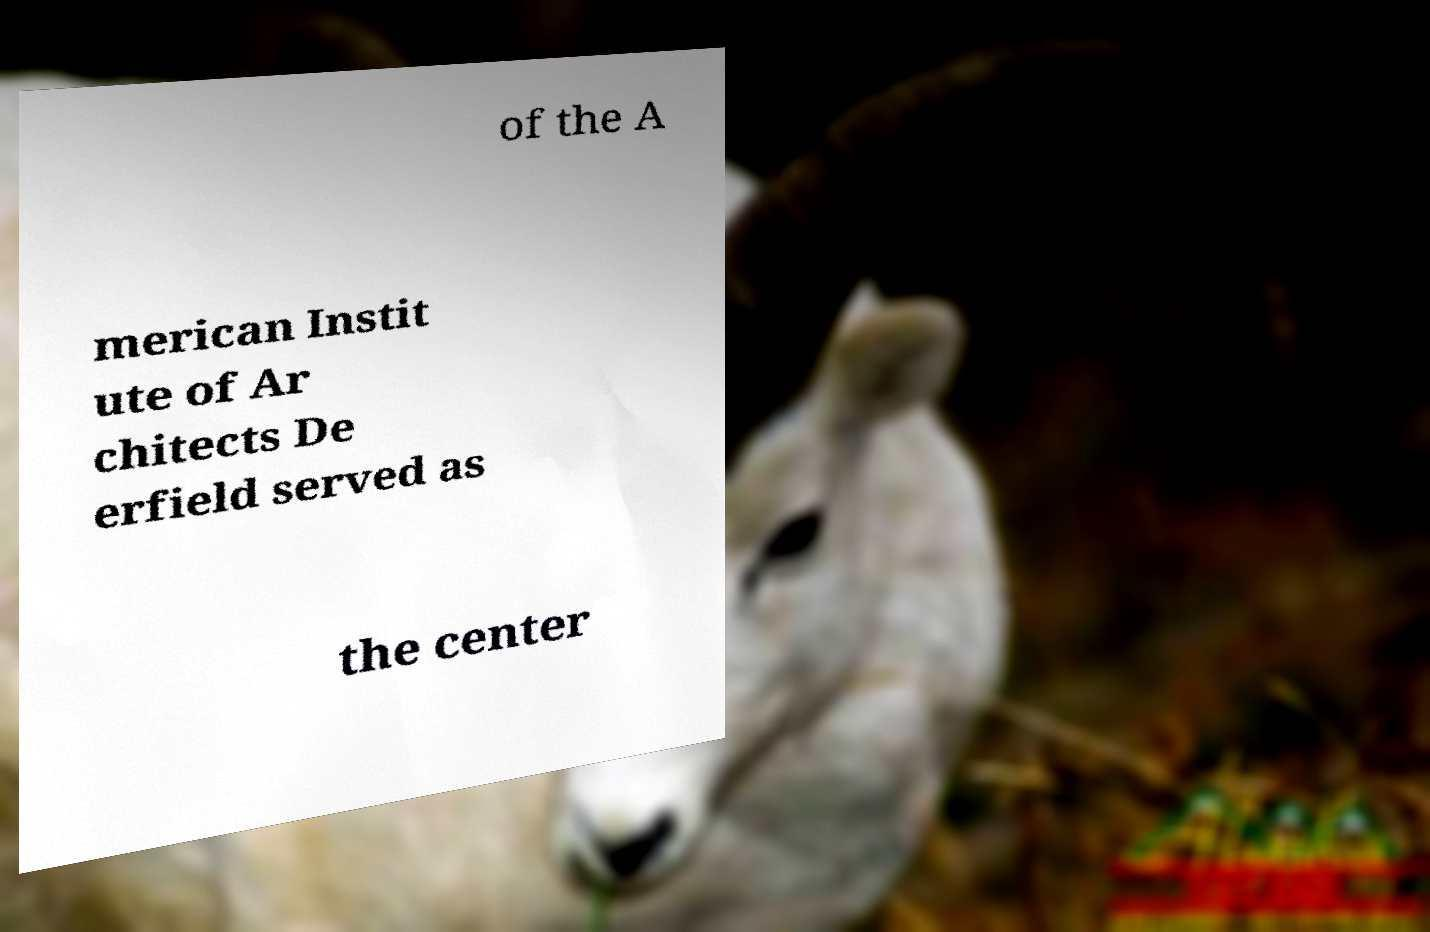Please identify and transcribe the text found in this image. of the A merican Instit ute of Ar chitects De erfield served as the center 